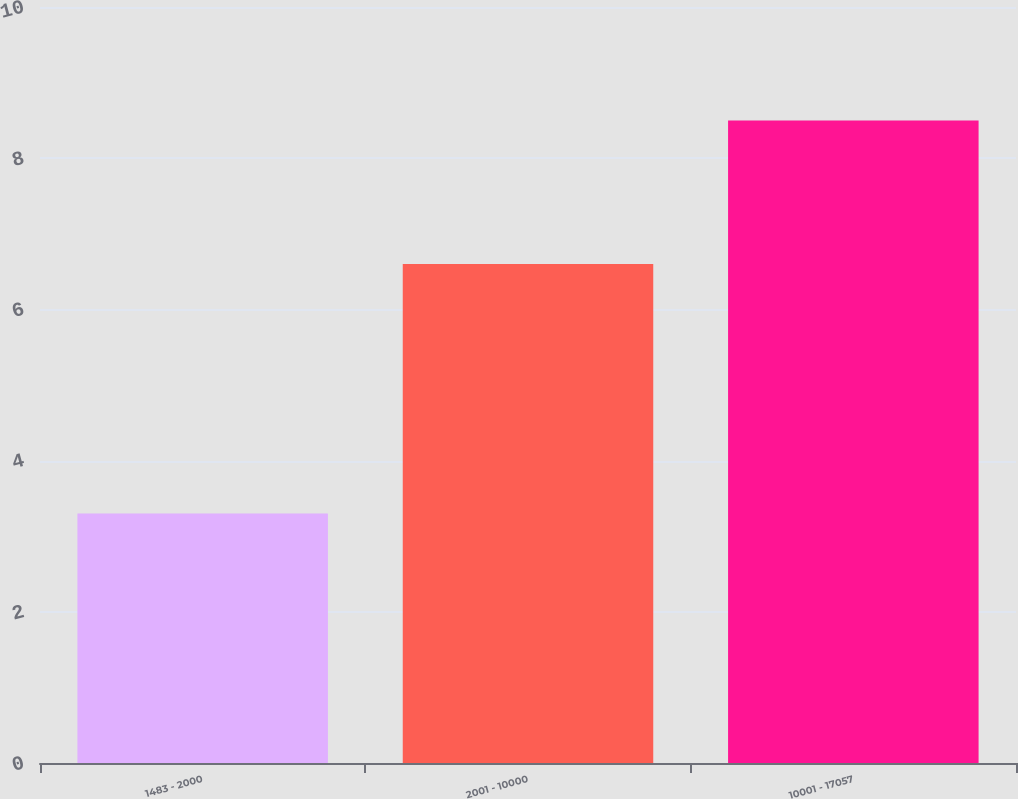Convert chart to OTSL. <chart><loc_0><loc_0><loc_500><loc_500><bar_chart><fcel>1483 - 2000<fcel>2001 - 10000<fcel>10001 - 17057<nl><fcel>3.3<fcel>6.6<fcel>8.5<nl></chart> 